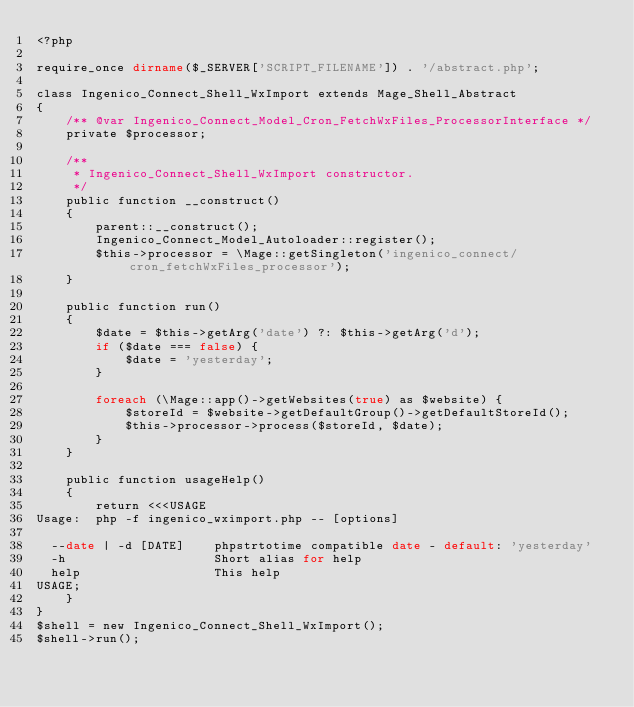<code> <loc_0><loc_0><loc_500><loc_500><_PHP_><?php

require_once dirname($_SERVER['SCRIPT_FILENAME']) . '/abstract.php';

class Ingenico_Connect_Shell_WxImport extends Mage_Shell_Abstract
{
    /** @var Ingenico_Connect_Model_Cron_FetchWxFiles_ProcessorInterface */
    private $processor;

    /**
     * Ingenico_Connect_Shell_WxImport constructor.
     */
    public function __construct()
    {
        parent::__construct();
        Ingenico_Connect_Model_Autoloader::register();
        $this->processor = \Mage::getSingleton('ingenico_connect/cron_fetchWxFiles_processor');
    }

    public function run()
    {
        $date = $this->getArg('date') ?: $this->getArg('d');
        if ($date === false) {
            $date = 'yesterday';
        }

        foreach (\Mage::app()->getWebsites(true) as $website) {
            $storeId = $website->getDefaultGroup()->getDefaultStoreId();
            $this->processor->process($storeId, $date);
        }
    }

    public function usageHelp()
    {
        return <<<USAGE
Usage:  php -f ingenico_wximport.php -- [options]

  --date | -d [DATE]    phpstrtotime compatible date - default: 'yesterday'
  -h                    Short alias for help
  help                  This help
USAGE;
    }
}
$shell = new Ingenico_Connect_Shell_WxImport();
$shell->run();
</code> 